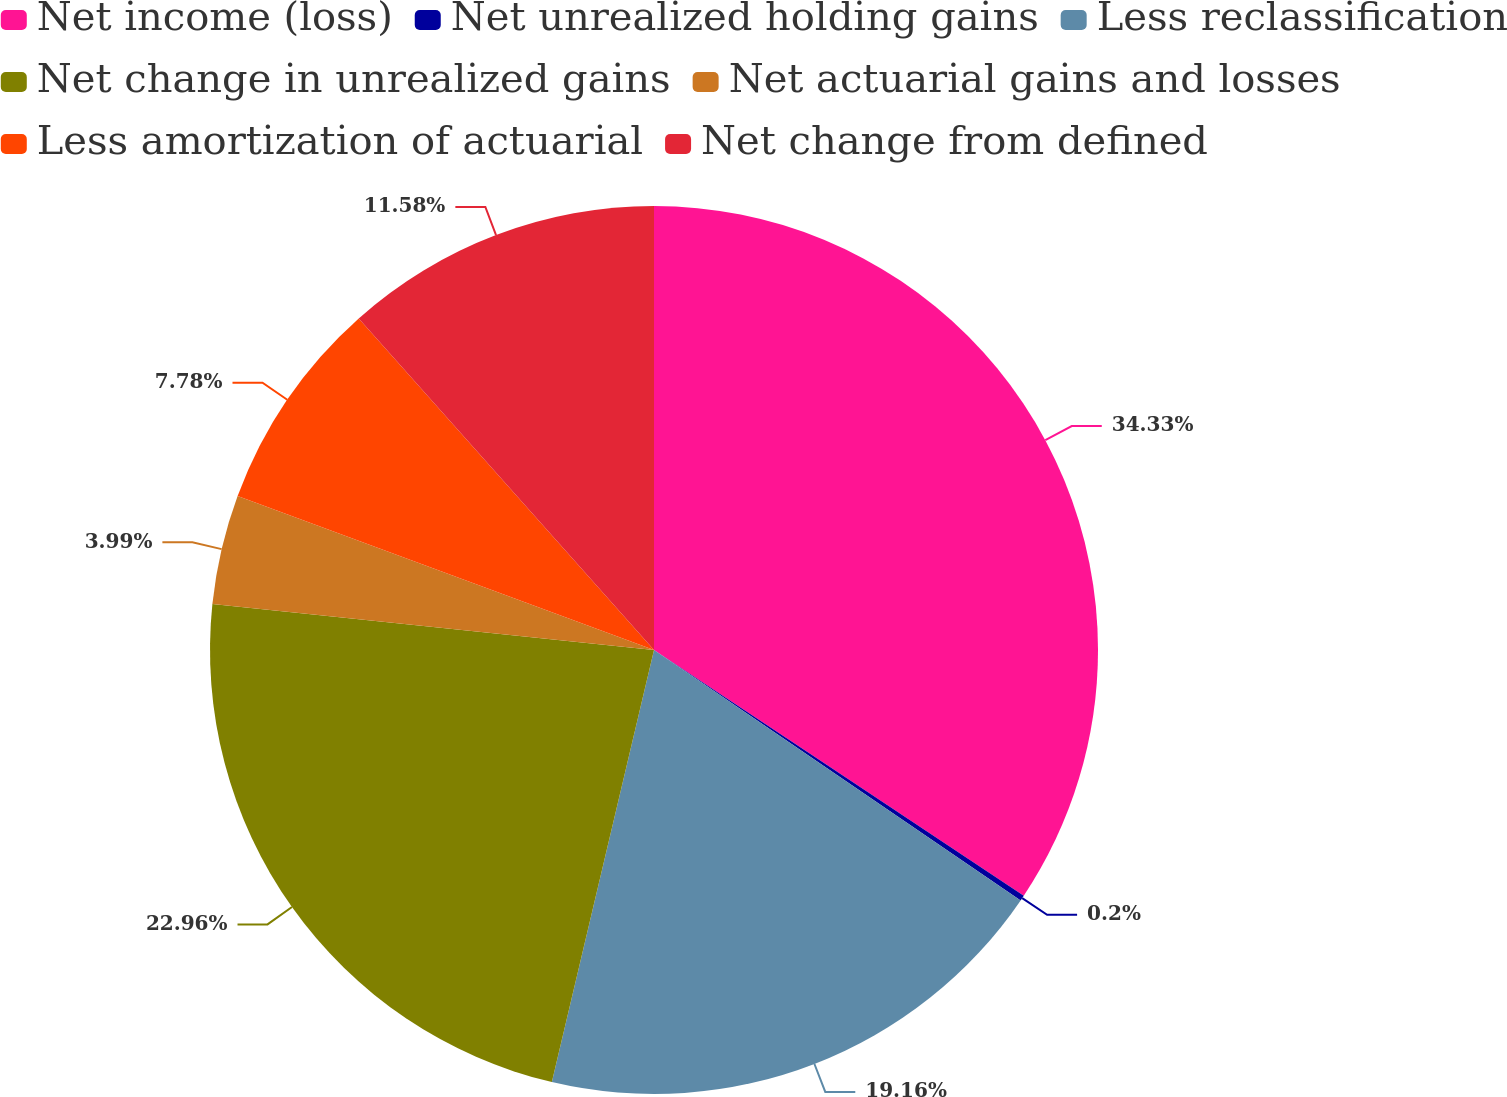<chart> <loc_0><loc_0><loc_500><loc_500><pie_chart><fcel>Net income (loss)<fcel>Net unrealized holding gains<fcel>Less reclassification<fcel>Net change in unrealized gains<fcel>Net actuarial gains and losses<fcel>Less amortization of actuarial<fcel>Net change from defined<nl><fcel>34.34%<fcel>0.2%<fcel>19.16%<fcel>22.96%<fcel>3.99%<fcel>7.78%<fcel>11.58%<nl></chart> 